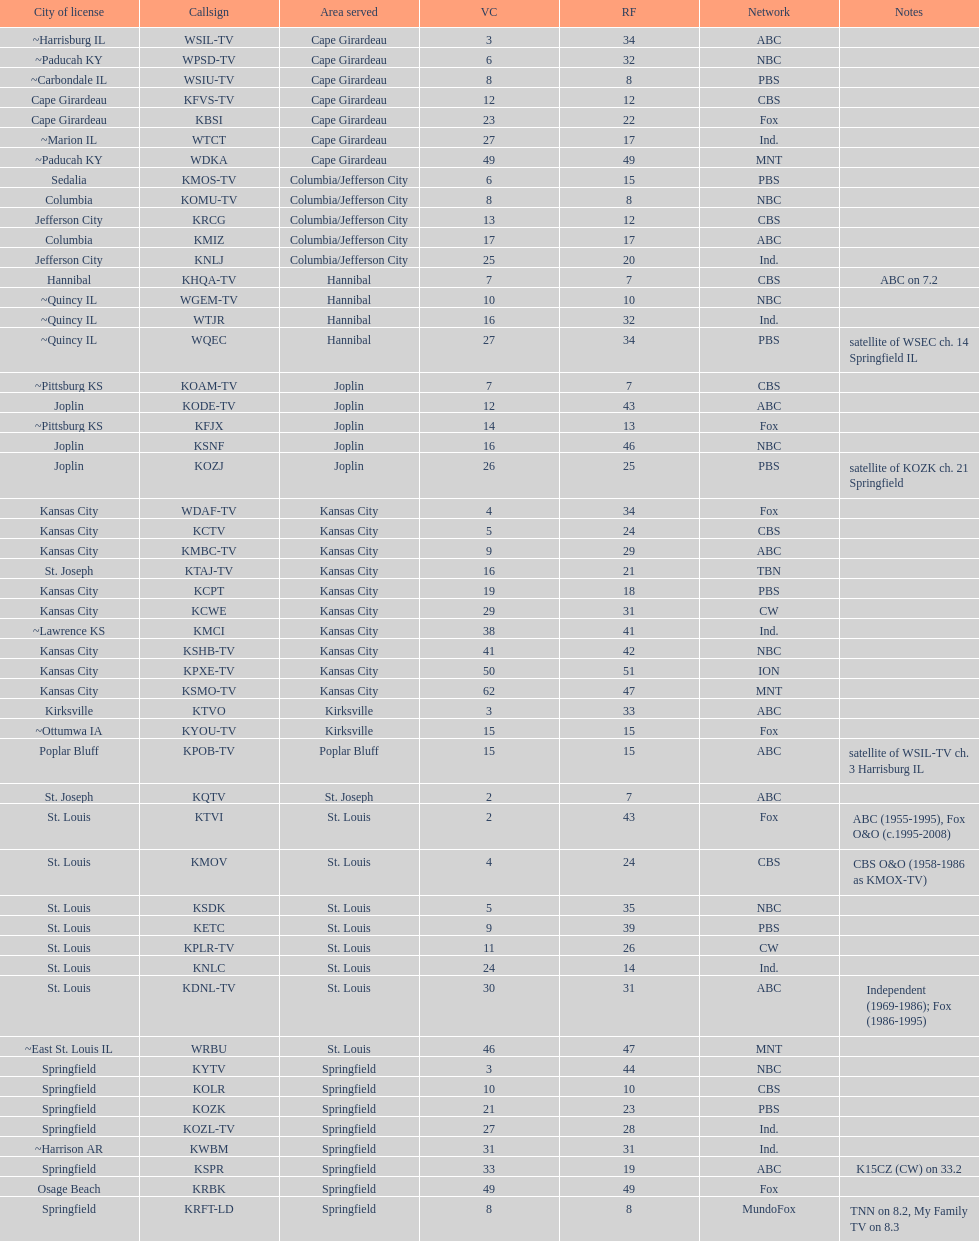Which station is licensed in the same city as koam-tv? KFJX. 